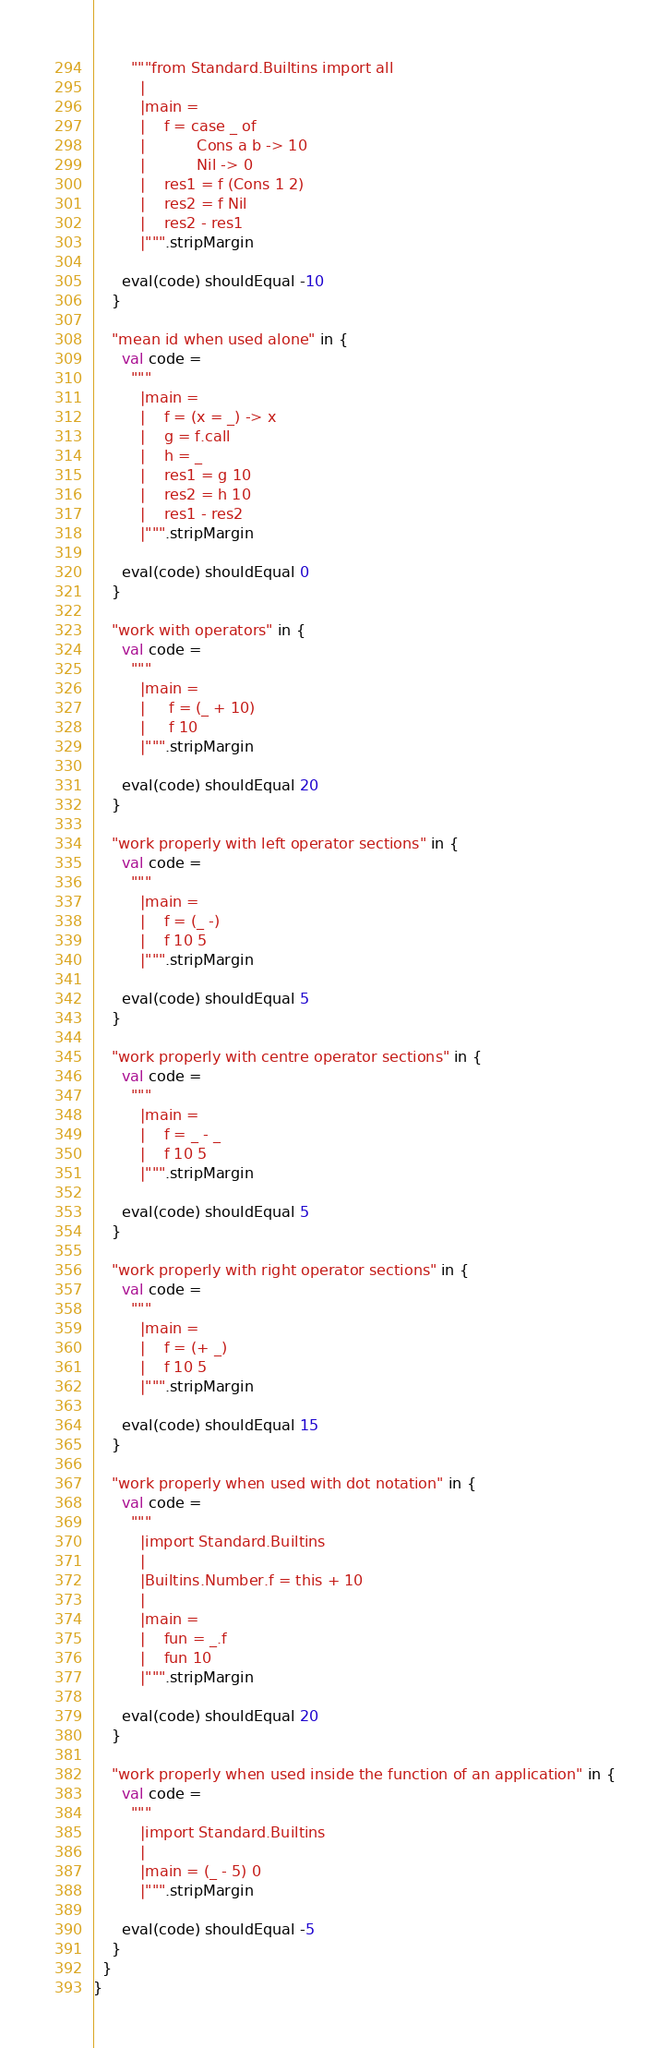Convert code to text. <code><loc_0><loc_0><loc_500><loc_500><_Scala_>        """from Standard.Builtins import all
          |
          |main =
          |    f = case _ of
          |           Cons a b -> 10
          |           Nil -> 0
          |    res1 = f (Cons 1 2)
          |    res2 = f Nil
          |    res2 - res1
          |""".stripMargin

      eval(code) shouldEqual -10
    }

    "mean id when used alone" in {
      val code =
        """
          |main =
          |    f = (x = _) -> x
          |    g = f.call
          |    h = _
          |    res1 = g 10
          |    res2 = h 10
          |    res1 - res2
          |""".stripMargin

      eval(code) shouldEqual 0
    }

    "work with operators" in {
      val code =
        """
          |main =
          |     f = (_ + 10)
          |     f 10
          |""".stripMargin

      eval(code) shouldEqual 20
    }

    "work properly with left operator sections" in {
      val code =
        """
          |main =
          |    f = (_ -)
          |    f 10 5
          |""".stripMargin

      eval(code) shouldEqual 5
    }

    "work properly with centre operator sections" in {
      val code =
        """
          |main =
          |    f = _ - _
          |    f 10 5
          |""".stripMargin

      eval(code) shouldEqual 5
    }

    "work properly with right operator sections" in {
      val code =
        """
          |main =
          |    f = (+ _)
          |    f 10 5
          |""".stripMargin

      eval(code) shouldEqual 15
    }

    "work properly when used with dot notation" in {
      val code =
        """
          |import Standard.Builtins
          |
          |Builtins.Number.f = this + 10
          |
          |main =
          |    fun = _.f
          |    fun 10
          |""".stripMargin

      eval(code) shouldEqual 20
    }

    "work properly when used inside the function of an application" in {
      val code =
        """
          |import Standard.Builtins
          |
          |main = (_ - 5) 0
          |""".stripMargin

      eval(code) shouldEqual -5
    }
  }
}
</code> 